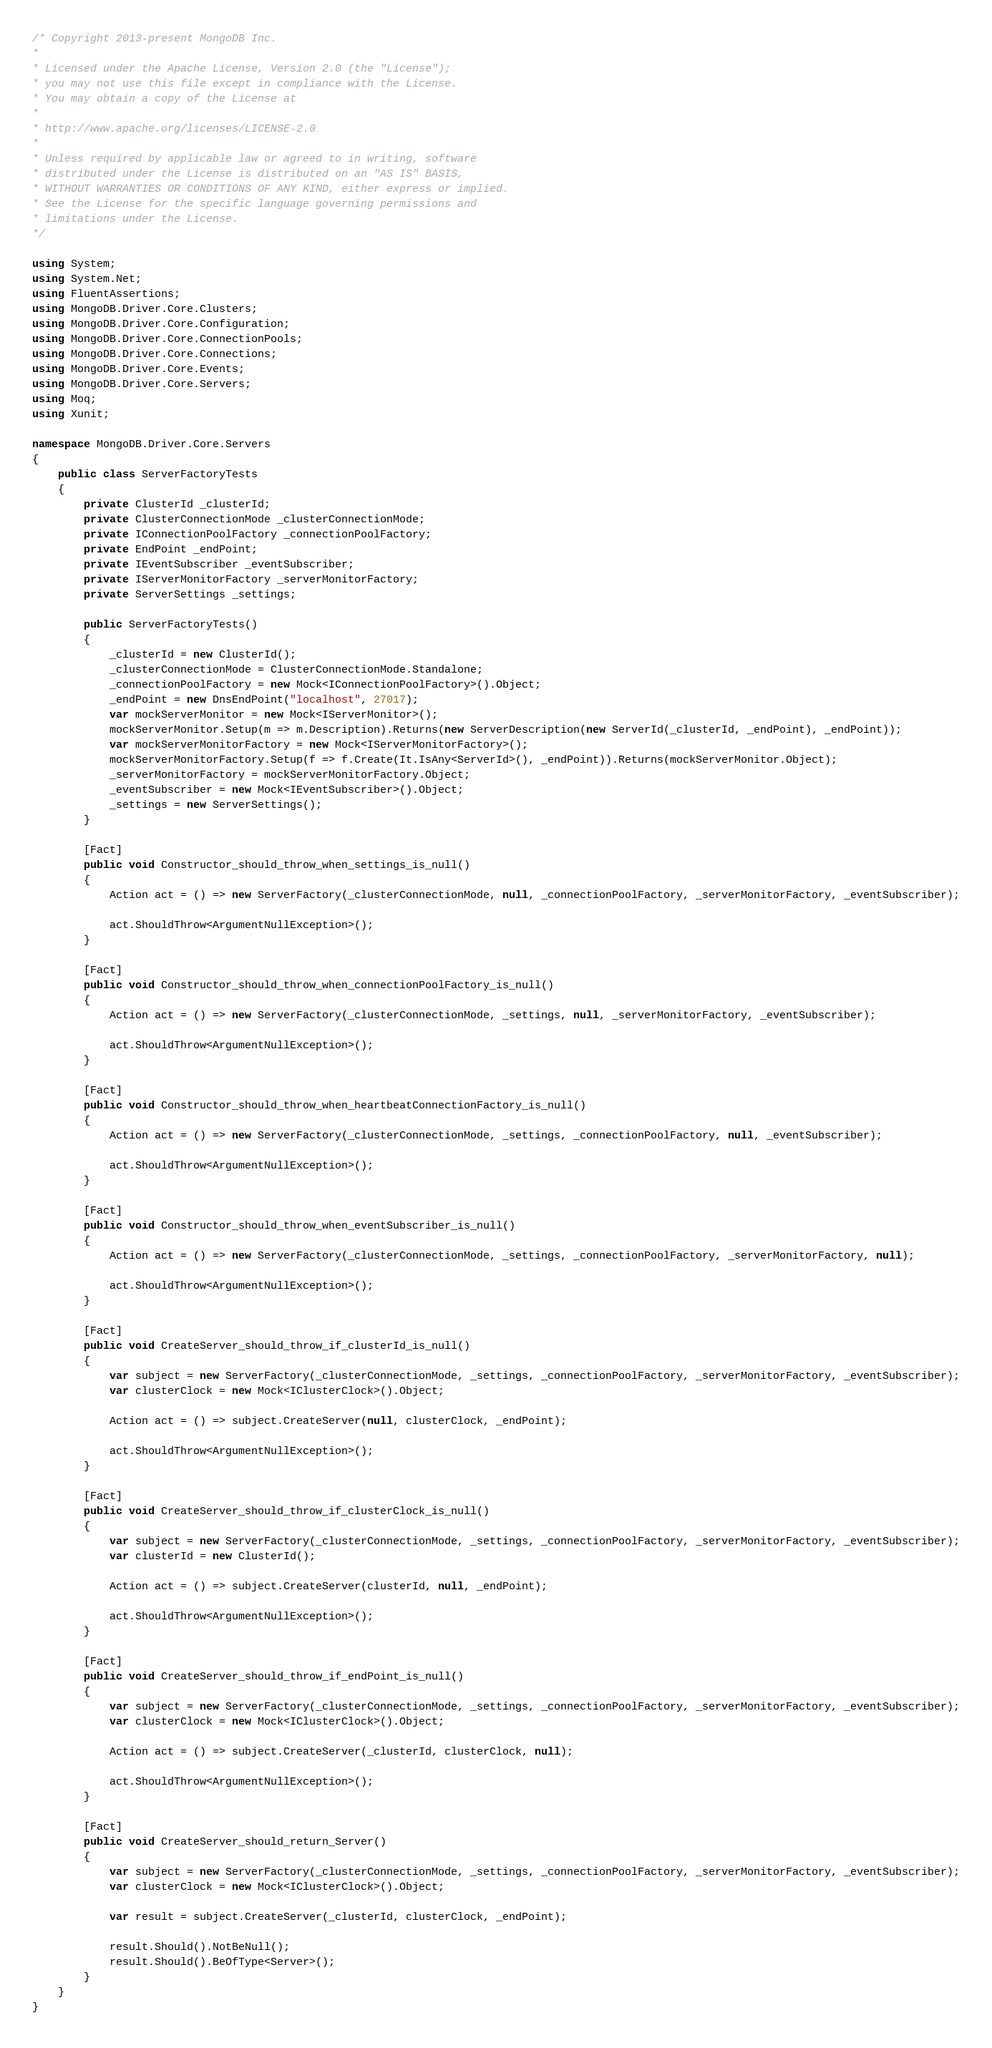Convert code to text. <code><loc_0><loc_0><loc_500><loc_500><_C#_>/* Copyright 2013-present MongoDB Inc.
*
* Licensed under the Apache License, Version 2.0 (the "License");
* you may not use this file except in compliance with the License.
* You may obtain a copy of the License at
*
* http://www.apache.org/licenses/LICENSE-2.0
*
* Unless required by applicable law or agreed to in writing, software
* distributed under the License is distributed on an "AS IS" BASIS,
* WITHOUT WARRANTIES OR CONDITIONS OF ANY KIND, either express or implied.
* See the License for the specific language governing permissions and
* limitations under the License.
*/

using System;
using System.Net;
using FluentAssertions;
using MongoDB.Driver.Core.Clusters;
using MongoDB.Driver.Core.Configuration;
using MongoDB.Driver.Core.ConnectionPools;
using MongoDB.Driver.Core.Connections;
using MongoDB.Driver.Core.Events;
using MongoDB.Driver.Core.Servers;
using Moq;
using Xunit;

namespace MongoDB.Driver.Core.Servers
{
    public class ServerFactoryTests
    {
        private ClusterId _clusterId;
        private ClusterConnectionMode _clusterConnectionMode;
        private IConnectionPoolFactory _connectionPoolFactory;
        private EndPoint _endPoint;
        private IEventSubscriber _eventSubscriber;
        private IServerMonitorFactory _serverMonitorFactory;
        private ServerSettings _settings;

        public ServerFactoryTests()
        {
            _clusterId = new ClusterId();
            _clusterConnectionMode = ClusterConnectionMode.Standalone;
            _connectionPoolFactory = new Mock<IConnectionPoolFactory>().Object;
            _endPoint = new DnsEndPoint("localhost", 27017);
            var mockServerMonitor = new Mock<IServerMonitor>();
            mockServerMonitor.Setup(m => m.Description).Returns(new ServerDescription(new ServerId(_clusterId, _endPoint), _endPoint));
            var mockServerMonitorFactory = new Mock<IServerMonitorFactory>();
            mockServerMonitorFactory.Setup(f => f.Create(It.IsAny<ServerId>(), _endPoint)).Returns(mockServerMonitor.Object);
            _serverMonitorFactory = mockServerMonitorFactory.Object;
            _eventSubscriber = new Mock<IEventSubscriber>().Object;
            _settings = new ServerSettings();
        }

        [Fact]
        public void Constructor_should_throw_when_settings_is_null()
        {
            Action act = () => new ServerFactory(_clusterConnectionMode, null, _connectionPoolFactory, _serverMonitorFactory, _eventSubscriber);

            act.ShouldThrow<ArgumentNullException>();
        }

        [Fact]
        public void Constructor_should_throw_when_connectionPoolFactory_is_null()
        {
            Action act = () => new ServerFactory(_clusterConnectionMode, _settings, null, _serverMonitorFactory, _eventSubscriber);

            act.ShouldThrow<ArgumentNullException>();
        }

        [Fact]
        public void Constructor_should_throw_when_heartbeatConnectionFactory_is_null()
        {
            Action act = () => new ServerFactory(_clusterConnectionMode, _settings, _connectionPoolFactory, null, _eventSubscriber);

            act.ShouldThrow<ArgumentNullException>();
        }

        [Fact]
        public void Constructor_should_throw_when_eventSubscriber_is_null()
        {
            Action act = () => new ServerFactory(_clusterConnectionMode, _settings, _connectionPoolFactory, _serverMonitorFactory, null);

            act.ShouldThrow<ArgumentNullException>();
        }

        [Fact]
        public void CreateServer_should_throw_if_clusterId_is_null()
        {
            var subject = new ServerFactory(_clusterConnectionMode, _settings, _connectionPoolFactory, _serverMonitorFactory, _eventSubscriber);
            var clusterClock = new Mock<IClusterClock>().Object;

            Action act = () => subject.CreateServer(null, clusterClock, _endPoint);

            act.ShouldThrow<ArgumentNullException>();
        }

        [Fact]
        public void CreateServer_should_throw_if_clusterClock_is_null()
        {
            var subject = new ServerFactory(_clusterConnectionMode, _settings, _connectionPoolFactory, _serverMonitorFactory, _eventSubscriber);
            var clusterId = new ClusterId();

            Action act = () => subject.CreateServer(clusterId, null, _endPoint);

            act.ShouldThrow<ArgumentNullException>();
        }

        [Fact]
        public void CreateServer_should_throw_if_endPoint_is_null()
        {
            var subject = new ServerFactory(_clusterConnectionMode, _settings, _connectionPoolFactory, _serverMonitorFactory, _eventSubscriber);
            var clusterClock = new Mock<IClusterClock>().Object;

            Action act = () => subject.CreateServer(_clusterId, clusterClock, null);

            act.ShouldThrow<ArgumentNullException>();
        }

        [Fact]
        public void CreateServer_should_return_Server()
        {
            var subject = new ServerFactory(_clusterConnectionMode, _settings, _connectionPoolFactory, _serverMonitorFactory, _eventSubscriber);
            var clusterClock = new Mock<IClusterClock>().Object;

            var result = subject.CreateServer(_clusterId, clusterClock, _endPoint);

            result.Should().NotBeNull();
            result.Should().BeOfType<Server>();
        }
    }
}
</code> 